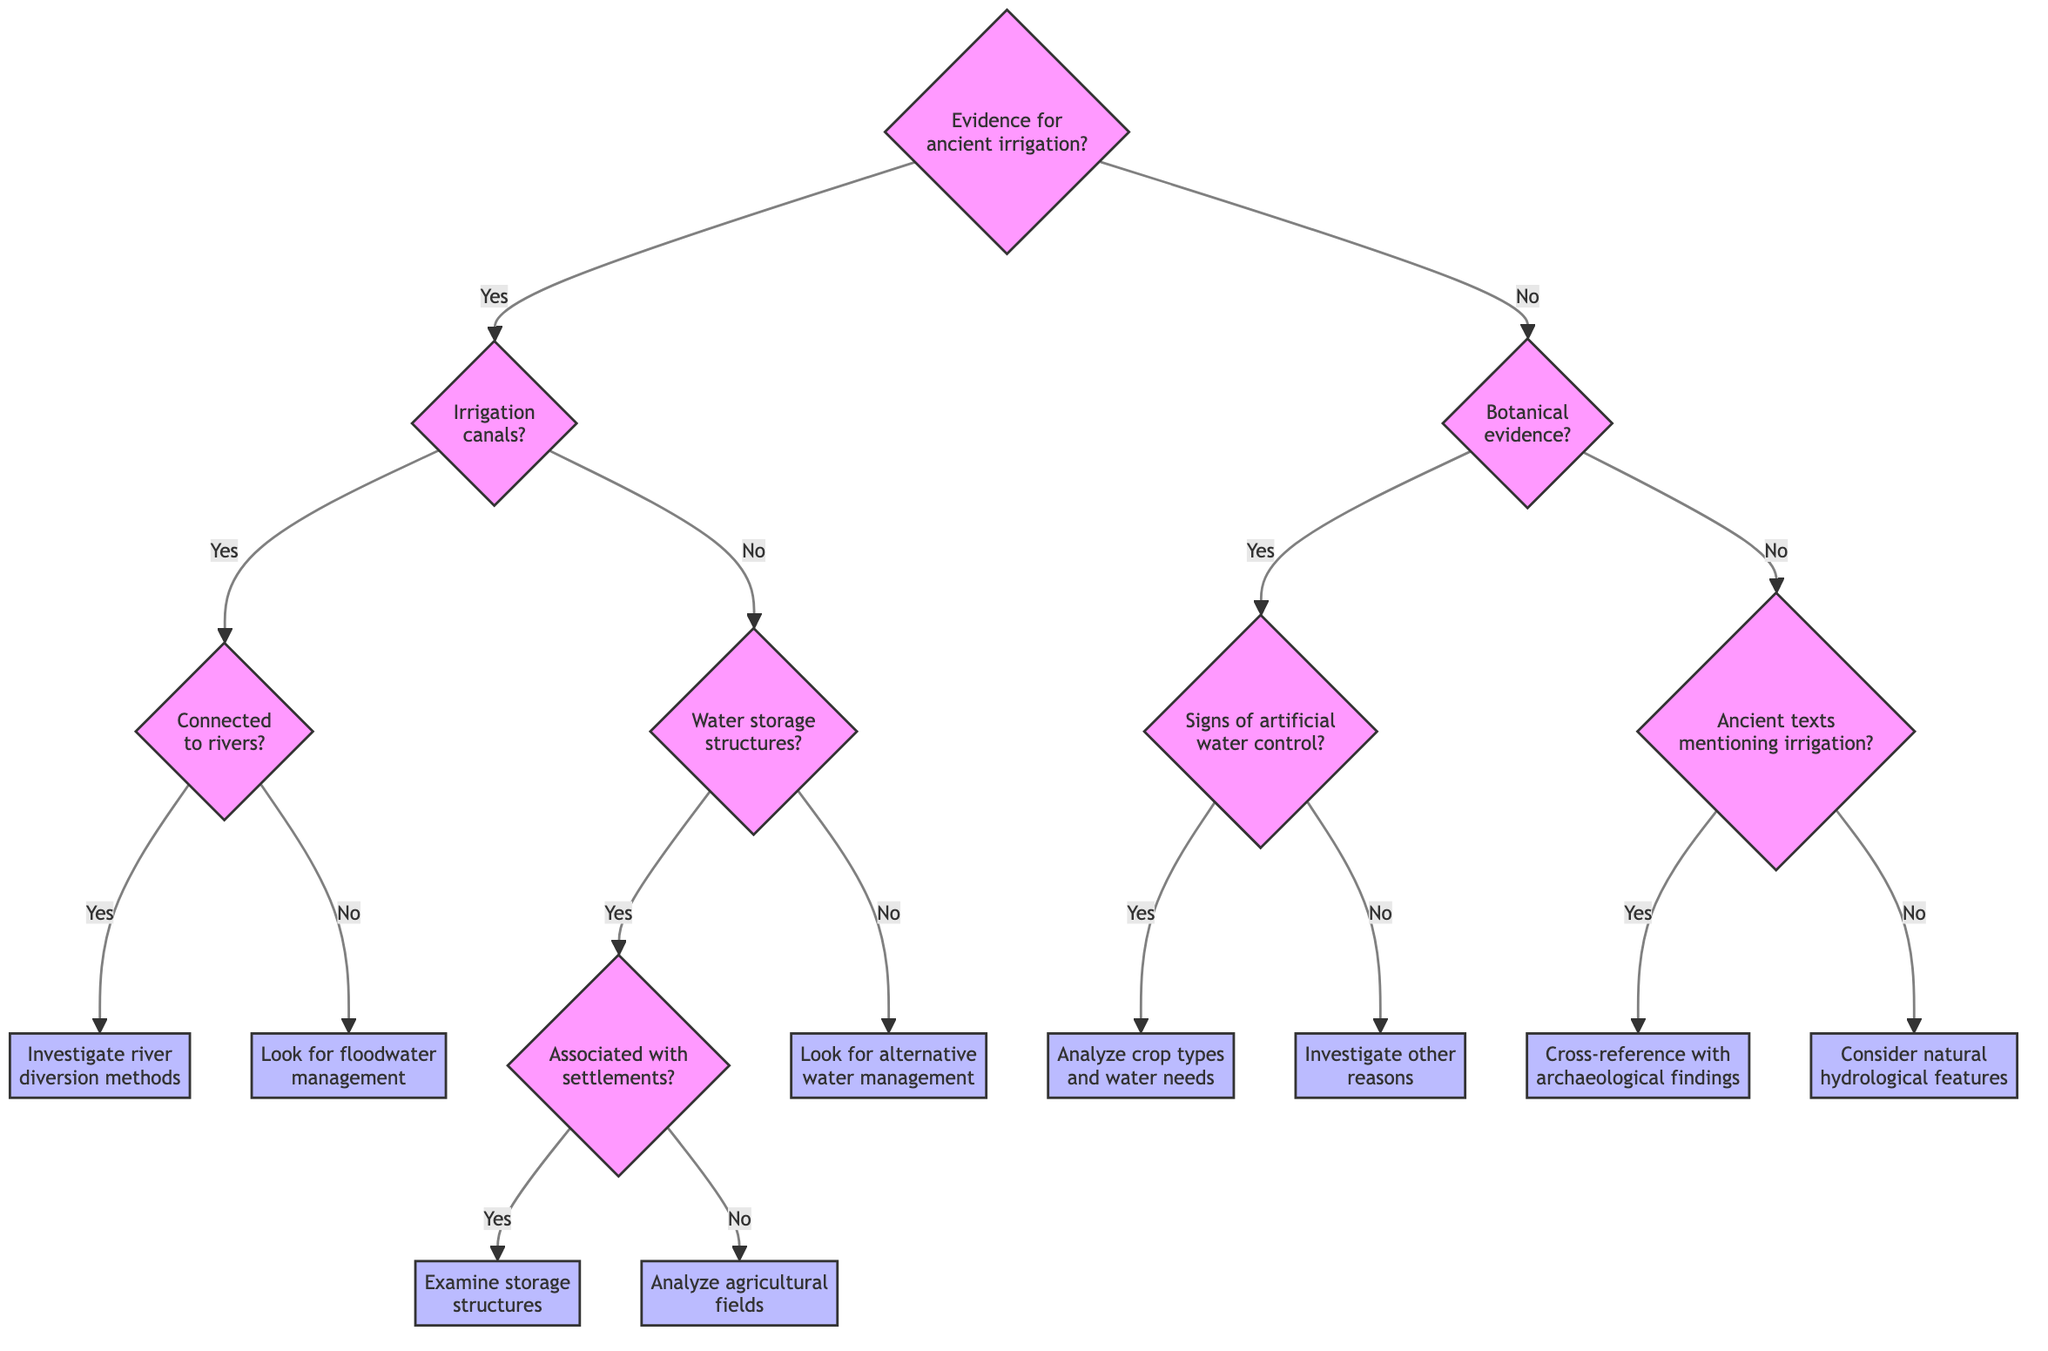What is the primary evidence for ancient irrigation techniques? The diagram starts with the root question asking for the primary evidence for ancient irrigation techniques, which can either be "Yes" indicating there is evidence, or "No" indicating there is not.
Answer: Evidence for ancient irrigation techniques What happens if there is evidence of irrigation canals? If there is evidence of irrigation canals ("Yes"), the next step is asking whether these canals are connected to rivers. This leads to further investigation based on the answer "Yes" or "No."
Answer: Investigate river diversion methods or Look for floodwater management Are the storage structures associated with ancient settlements? This question is reached after confirming that there are water storage structures. It asks for the relationship between those structures and ancient settlements, leading to different actions based on the answer.
Answer: Examine the size and distribution of storage structures or Analyze for agricultural fields and potential irrigation distribution What action is taken if there are signs of artificial water control in plant remains? If plant remains show signs of artificial water control, the action taken is to analyze the types of crops and their water needs, indicating a connection between irrigation practices and agriculture.
Answer: Analyze the types of crops and their water needs How many action nodes follow the "No" pathway from the main question? Following the "No" branch from the primary question ("What is the primary evidence for ancient irrigation techniques?"), we see that there are three actions listed which represent the outcomes of the analysis of ancient texts, confirming the importance of interpreting textual evidence as well.
Answer: 3 What is the next question if there is no evidence of irrigation canals? If there is no evidence of irrigation canals, the next question becomes whether there is evidence of water storage structures, indicating an alternative assessment of irrigation methods.
Answer: Is there evidence of water storage structures? What action is determined if ancient texts do not mention irrigation? In the case where ancient texts do not mention irrigation, the next action is to consider natural hydrological features as potential sources for irrigation, indicating a fallback plan in the investigation process.
Answer: Consider natural hydrological features as potential irrigation sources What distinguishes a reasoning question from a descriptive question in this diagram? Reasoning questions require synthesizing information from multiple parts of the diagram to derive the answer, whereas descriptive questions focus on obtaining straightforward facts directly presented in the diagram without further analysis.
Answer: Involves synthesis vs. Simple fact retrieval What is the relationship between the presence of irrigation canals and river connections? The presence of irrigation canals prompts further investigation into whether these canals are connected to rivers, suggesting that the relationship is crucial in determining the methods used for irrigation and their geographic context.
Answer: Investigate river diversion methods or Look for floodwater management 